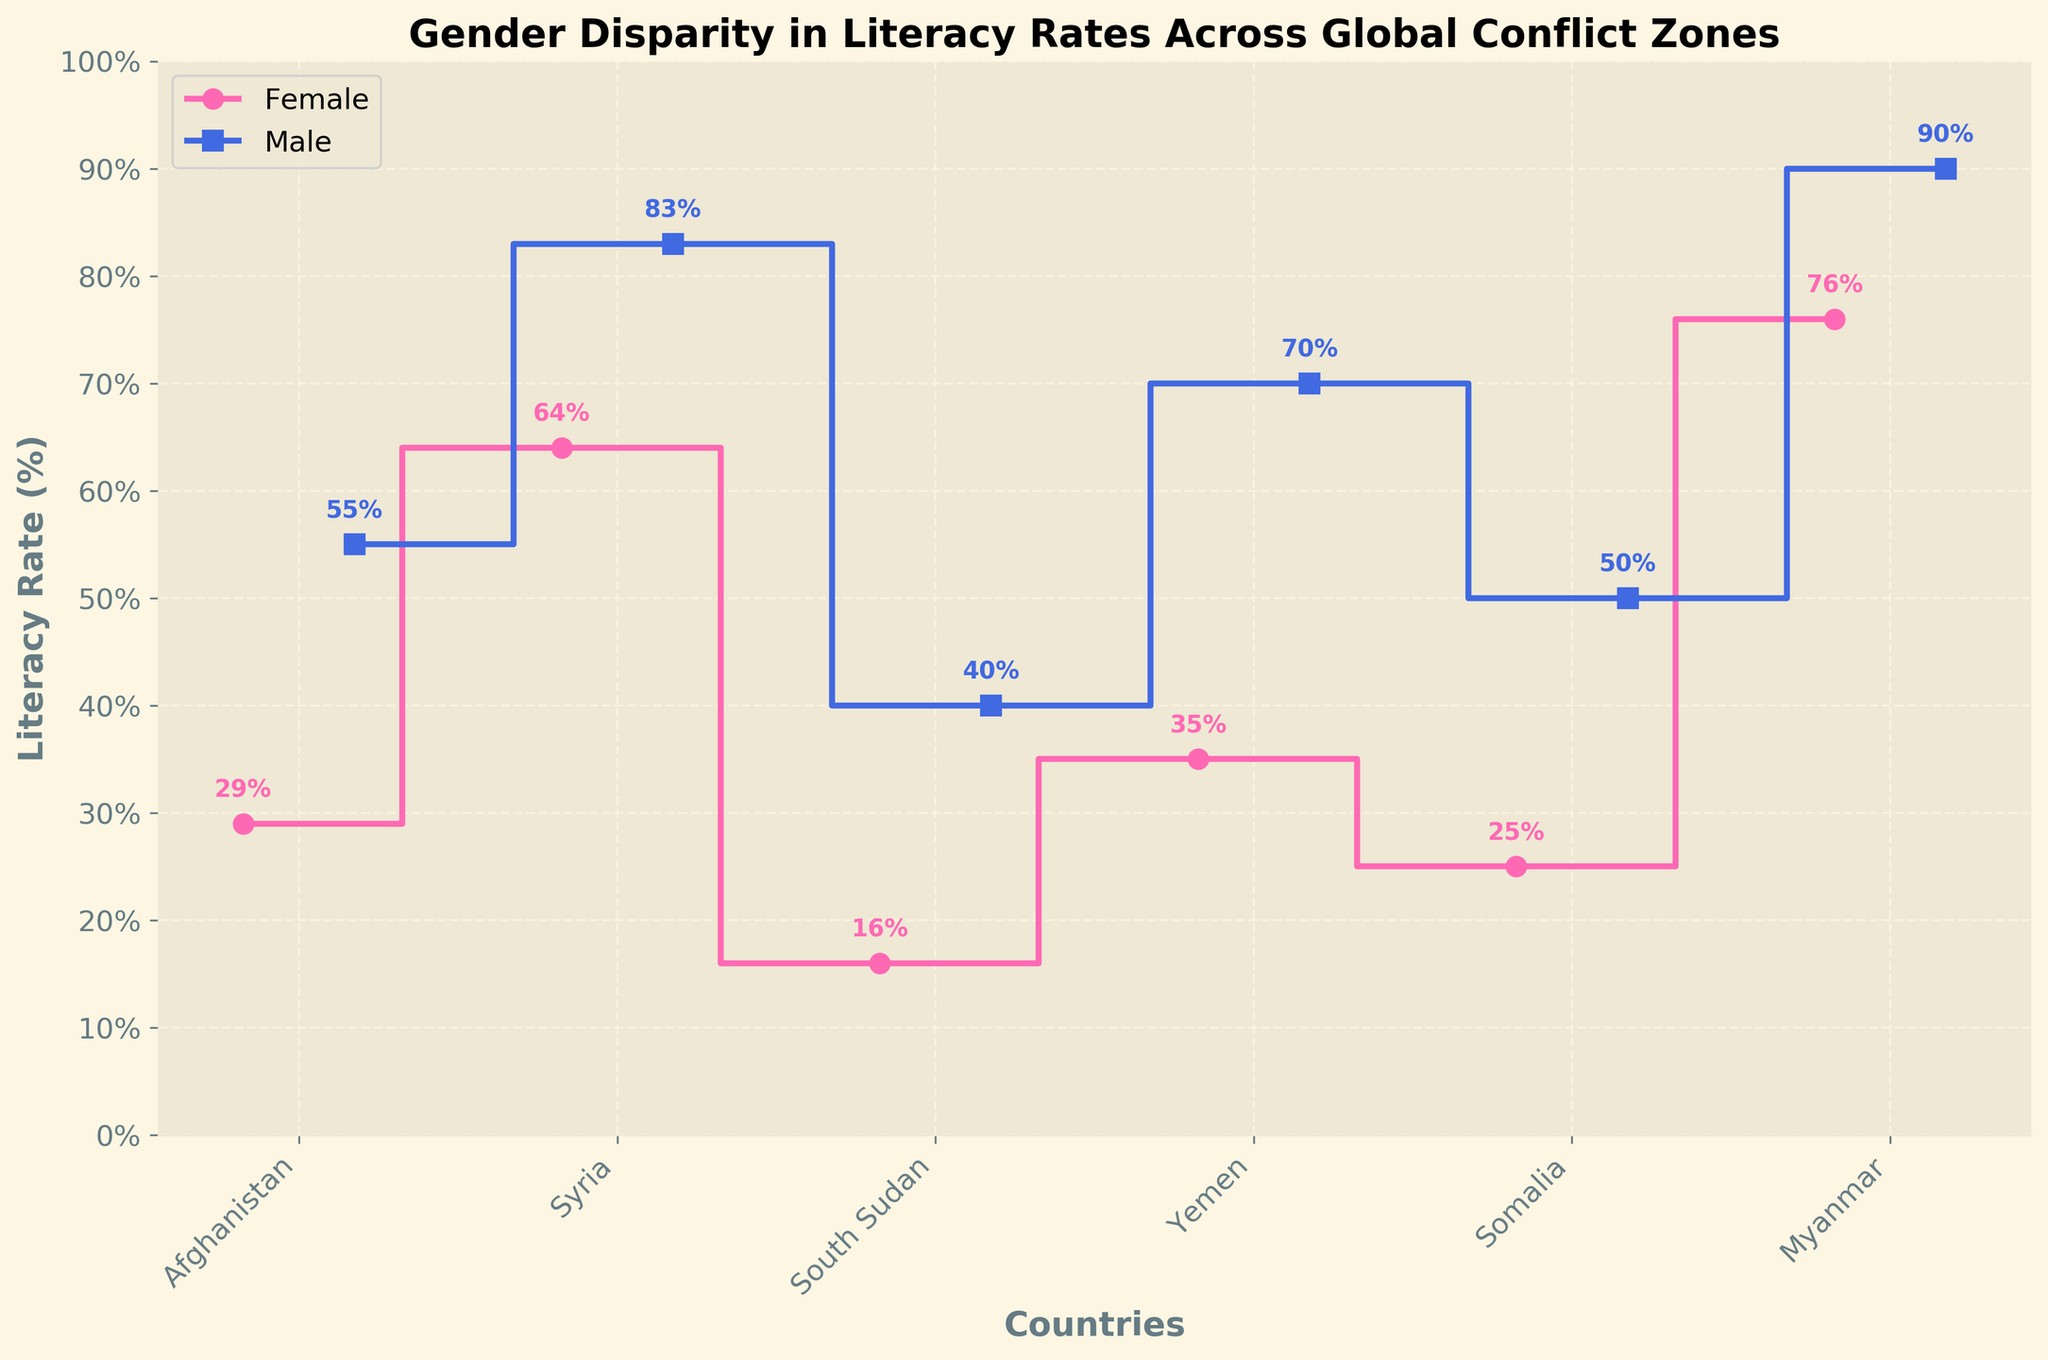What is the title of the plot? The title is usually displayed at the top center of the plot and it helps in understanding the subject of the visualization.
Answer: Gender Disparity in Literacy Rates Across Global Conflict Zones Which country has the highest literacy rate for females? By examining the highest point along the "Female" step line, we can identify the country associated with this point. In this plot, the highest literacy rate for females is noted at 76%.
Answer: Myanmar Which country has the lowest literacy rate for males? By looking at the lowest point along the "Male" step line, we can determine the country corresponding to this point. Here, the lowest literacy rate for males appears as 40%.
Answer: South Sudan What is the literacy rate difference between males and females in Yemen? The difference can be calculated by noting the literacy rates for males and females in Yemen and subtracting the female rate from the male rate: 70% (Male) - 35% (Female).
Answer: 35% Which gender generally has higher literacy rates across all countries in the plot? By comparing the general trend of the step lines visually, we can observe that the male step line consistently shows higher values than the female step line.
Answer: Male In which country is the gender disparity in literacy rates the largest? To find the country with the largest gender disparity, we calculate the differences between the male and female literacy rates for each country. The largest gap is in Yemen: 70% - 35% = 35%.
Answer: Yemen Which country shows a relatively small gender disparity in literacy rates? By examining the difference in literacy rates between males and females for each country, we find the smallest gap. In this plot, the smallest disparity is in Syria: 83% (Male) - 64% (Female) = 19%.
Answer: Syria What is the average literacy rate for females in all the countries shown? Add all the literacy rates for females and divide by the number of countries: (29 + 64 + 16 + 35 + 25 + 76) / 6 = 40.83%.
Answer: 40.83% How does the literacy rate of males in Somalia compare to males in Afghanistan? By comparing the heights of the respective step lines, we find that the male literacy rate in Somalia is 50%, while in Afghanistan, it is 55%. Thus, Somalia has a slightly lower rate.
Answer: Somalia is lower Which country has a female literacy rate closest to the overall average female literacy rate across the countries? First, calculate the average female literacy rate as 40.83%. Then compare it to each female literacy rate and identify the closest match: (35% in Yemen is the closest to 40.83%)
Answer: Yemen 